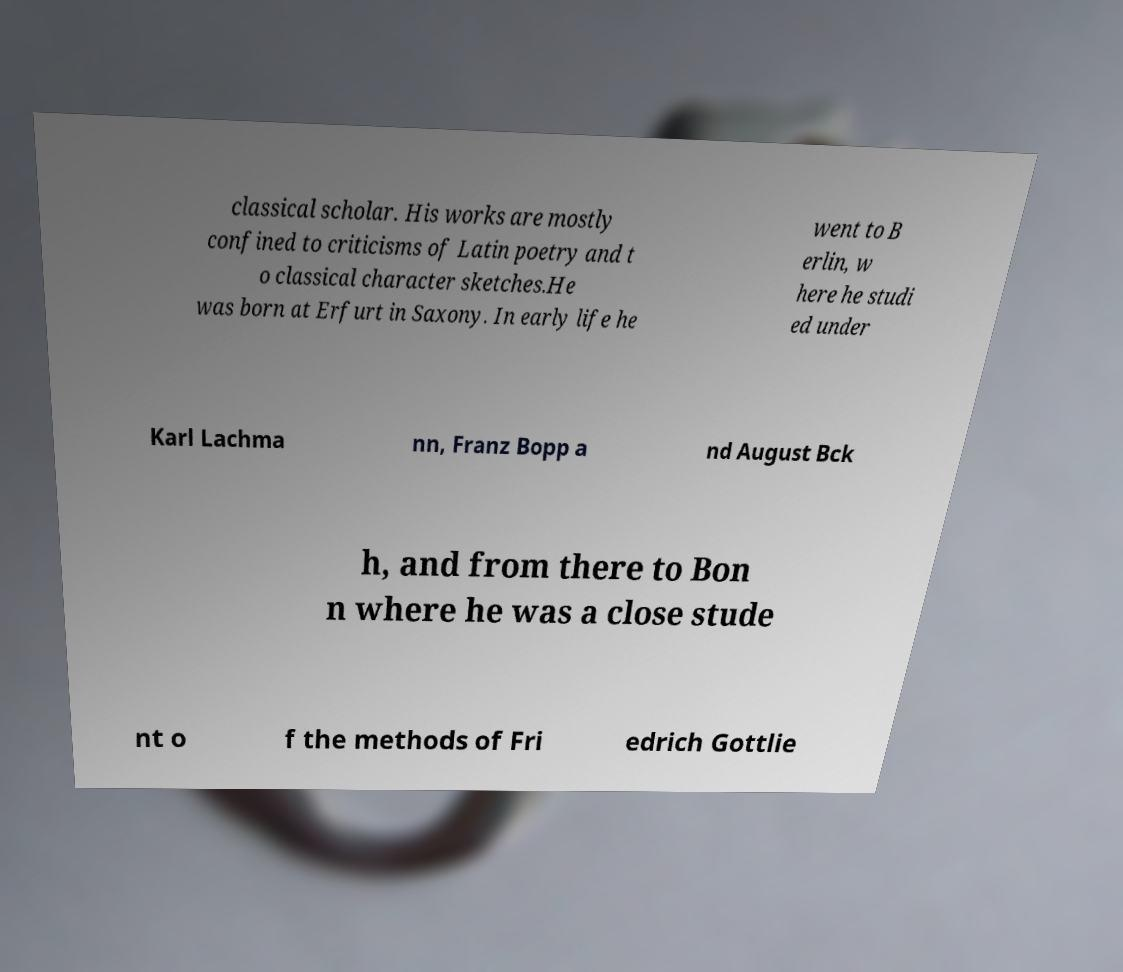There's text embedded in this image that I need extracted. Can you transcribe it verbatim? classical scholar. His works are mostly confined to criticisms of Latin poetry and t o classical character sketches.He was born at Erfurt in Saxony. In early life he went to B erlin, w here he studi ed under Karl Lachma nn, Franz Bopp a nd August Bck h, and from there to Bon n where he was a close stude nt o f the methods of Fri edrich Gottlie 